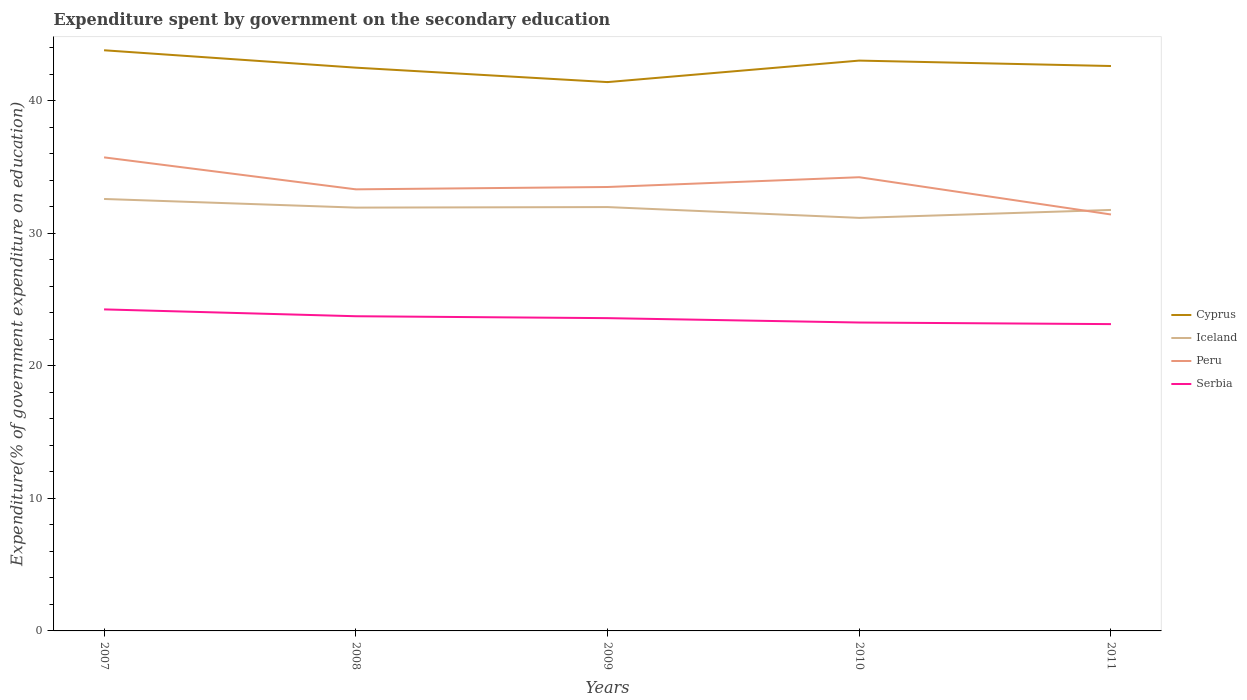How many different coloured lines are there?
Provide a short and direct response. 4. Is the number of lines equal to the number of legend labels?
Give a very brief answer. Yes. Across all years, what is the maximum expenditure spent by government on the secondary education in Iceland?
Give a very brief answer. 31.15. In which year was the expenditure spent by government on the secondary education in Serbia maximum?
Provide a short and direct response. 2011. What is the total expenditure spent by government on the secondary education in Peru in the graph?
Offer a very short reply. -0.74. What is the difference between the highest and the second highest expenditure spent by government on the secondary education in Serbia?
Your answer should be very brief. 1.11. What is the difference between the highest and the lowest expenditure spent by government on the secondary education in Cyprus?
Offer a very short reply. 2. Is the expenditure spent by government on the secondary education in Iceland strictly greater than the expenditure spent by government on the secondary education in Serbia over the years?
Provide a short and direct response. No. How many lines are there?
Your response must be concise. 4. How many years are there in the graph?
Give a very brief answer. 5. Does the graph contain any zero values?
Offer a very short reply. No. Does the graph contain grids?
Provide a short and direct response. No. Where does the legend appear in the graph?
Your response must be concise. Center right. How many legend labels are there?
Keep it short and to the point. 4. What is the title of the graph?
Provide a succinct answer. Expenditure spent by government on the secondary education. What is the label or title of the X-axis?
Offer a terse response. Years. What is the label or title of the Y-axis?
Offer a terse response. Expenditure(% of government expenditure on education). What is the Expenditure(% of government expenditure on education) in Cyprus in 2007?
Ensure brevity in your answer.  43.79. What is the Expenditure(% of government expenditure on education) of Iceland in 2007?
Your answer should be very brief. 32.58. What is the Expenditure(% of government expenditure on education) of Peru in 2007?
Provide a short and direct response. 35.71. What is the Expenditure(% of government expenditure on education) in Serbia in 2007?
Offer a very short reply. 24.25. What is the Expenditure(% of government expenditure on education) in Cyprus in 2008?
Offer a very short reply. 42.48. What is the Expenditure(% of government expenditure on education) in Iceland in 2008?
Provide a succinct answer. 31.92. What is the Expenditure(% of government expenditure on education) in Peru in 2008?
Give a very brief answer. 33.3. What is the Expenditure(% of government expenditure on education) of Serbia in 2008?
Your response must be concise. 23.73. What is the Expenditure(% of government expenditure on education) in Cyprus in 2009?
Offer a very short reply. 41.39. What is the Expenditure(% of government expenditure on education) of Iceland in 2009?
Your answer should be very brief. 31.96. What is the Expenditure(% of government expenditure on education) of Peru in 2009?
Provide a short and direct response. 33.48. What is the Expenditure(% of government expenditure on education) in Serbia in 2009?
Offer a very short reply. 23.59. What is the Expenditure(% of government expenditure on education) in Cyprus in 2010?
Offer a very short reply. 43.01. What is the Expenditure(% of government expenditure on education) in Iceland in 2010?
Provide a succinct answer. 31.15. What is the Expenditure(% of government expenditure on education) of Peru in 2010?
Provide a succinct answer. 34.22. What is the Expenditure(% of government expenditure on education) in Serbia in 2010?
Provide a succinct answer. 23.26. What is the Expenditure(% of government expenditure on education) in Cyprus in 2011?
Make the answer very short. 42.6. What is the Expenditure(% of government expenditure on education) of Iceland in 2011?
Offer a very short reply. 31.75. What is the Expenditure(% of government expenditure on education) in Peru in 2011?
Keep it short and to the point. 31.41. What is the Expenditure(% of government expenditure on education) in Serbia in 2011?
Your answer should be compact. 23.14. Across all years, what is the maximum Expenditure(% of government expenditure on education) of Cyprus?
Provide a succinct answer. 43.79. Across all years, what is the maximum Expenditure(% of government expenditure on education) of Iceland?
Keep it short and to the point. 32.58. Across all years, what is the maximum Expenditure(% of government expenditure on education) of Peru?
Your answer should be compact. 35.71. Across all years, what is the maximum Expenditure(% of government expenditure on education) of Serbia?
Make the answer very short. 24.25. Across all years, what is the minimum Expenditure(% of government expenditure on education) of Cyprus?
Make the answer very short. 41.39. Across all years, what is the minimum Expenditure(% of government expenditure on education) in Iceland?
Offer a very short reply. 31.15. Across all years, what is the minimum Expenditure(% of government expenditure on education) in Peru?
Keep it short and to the point. 31.41. Across all years, what is the minimum Expenditure(% of government expenditure on education) in Serbia?
Your response must be concise. 23.14. What is the total Expenditure(% of government expenditure on education) of Cyprus in the graph?
Your response must be concise. 213.27. What is the total Expenditure(% of government expenditure on education) in Iceland in the graph?
Your answer should be compact. 159.36. What is the total Expenditure(% of government expenditure on education) in Peru in the graph?
Provide a short and direct response. 168.11. What is the total Expenditure(% of government expenditure on education) of Serbia in the graph?
Provide a succinct answer. 117.96. What is the difference between the Expenditure(% of government expenditure on education) in Cyprus in 2007 and that in 2008?
Your response must be concise. 1.31. What is the difference between the Expenditure(% of government expenditure on education) of Iceland in 2007 and that in 2008?
Ensure brevity in your answer.  0.65. What is the difference between the Expenditure(% of government expenditure on education) in Peru in 2007 and that in 2008?
Offer a very short reply. 2.41. What is the difference between the Expenditure(% of government expenditure on education) in Serbia in 2007 and that in 2008?
Ensure brevity in your answer.  0.52. What is the difference between the Expenditure(% of government expenditure on education) in Cyprus in 2007 and that in 2009?
Your answer should be compact. 2.4. What is the difference between the Expenditure(% of government expenditure on education) in Iceland in 2007 and that in 2009?
Provide a succinct answer. 0.61. What is the difference between the Expenditure(% of government expenditure on education) of Peru in 2007 and that in 2009?
Make the answer very short. 2.23. What is the difference between the Expenditure(% of government expenditure on education) of Serbia in 2007 and that in 2009?
Offer a terse response. 0.66. What is the difference between the Expenditure(% of government expenditure on education) in Cyprus in 2007 and that in 2010?
Provide a short and direct response. 0.78. What is the difference between the Expenditure(% of government expenditure on education) of Iceland in 2007 and that in 2010?
Offer a terse response. 1.43. What is the difference between the Expenditure(% of government expenditure on education) in Peru in 2007 and that in 2010?
Provide a short and direct response. 1.5. What is the difference between the Expenditure(% of government expenditure on education) in Serbia in 2007 and that in 2010?
Ensure brevity in your answer.  0.99. What is the difference between the Expenditure(% of government expenditure on education) in Cyprus in 2007 and that in 2011?
Provide a succinct answer. 1.19. What is the difference between the Expenditure(% of government expenditure on education) in Iceland in 2007 and that in 2011?
Ensure brevity in your answer.  0.83. What is the difference between the Expenditure(% of government expenditure on education) of Peru in 2007 and that in 2011?
Provide a short and direct response. 4.31. What is the difference between the Expenditure(% of government expenditure on education) in Serbia in 2007 and that in 2011?
Offer a very short reply. 1.11. What is the difference between the Expenditure(% of government expenditure on education) of Cyprus in 2008 and that in 2009?
Provide a short and direct response. 1.09. What is the difference between the Expenditure(% of government expenditure on education) in Iceland in 2008 and that in 2009?
Offer a terse response. -0.04. What is the difference between the Expenditure(% of government expenditure on education) in Peru in 2008 and that in 2009?
Provide a short and direct response. -0.18. What is the difference between the Expenditure(% of government expenditure on education) of Serbia in 2008 and that in 2009?
Provide a short and direct response. 0.14. What is the difference between the Expenditure(% of government expenditure on education) in Cyprus in 2008 and that in 2010?
Offer a very short reply. -0.53. What is the difference between the Expenditure(% of government expenditure on education) in Iceland in 2008 and that in 2010?
Make the answer very short. 0.77. What is the difference between the Expenditure(% of government expenditure on education) of Peru in 2008 and that in 2010?
Your answer should be compact. -0.91. What is the difference between the Expenditure(% of government expenditure on education) in Serbia in 2008 and that in 2010?
Give a very brief answer. 0.47. What is the difference between the Expenditure(% of government expenditure on education) of Cyprus in 2008 and that in 2011?
Provide a succinct answer. -0.12. What is the difference between the Expenditure(% of government expenditure on education) in Iceland in 2008 and that in 2011?
Keep it short and to the point. 0.18. What is the difference between the Expenditure(% of government expenditure on education) in Peru in 2008 and that in 2011?
Provide a succinct answer. 1.9. What is the difference between the Expenditure(% of government expenditure on education) in Serbia in 2008 and that in 2011?
Make the answer very short. 0.59. What is the difference between the Expenditure(% of government expenditure on education) in Cyprus in 2009 and that in 2010?
Ensure brevity in your answer.  -1.62. What is the difference between the Expenditure(% of government expenditure on education) of Iceland in 2009 and that in 2010?
Offer a very short reply. 0.81. What is the difference between the Expenditure(% of government expenditure on education) in Peru in 2009 and that in 2010?
Provide a succinct answer. -0.74. What is the difference between the Expenditure(% of government expenditure on education) of Serbia in 2009 and that in 2010?
Your response must be concise. 0.33. What is the difference between the Expenditure(% of government expenditure on education) in Cyprus in 2009 and that in 2011?
Ensure brevity in your answer.  -1.21. What is the difference between the Expenditure(% of government expenditure on education) in Iceland in 2009 and that in 2011?
Your response must be concise. 0.22. What is the difference between the Expenditure(% of government expenditure on education) in Peru in 2009 and that in 2011?
Provide a short and direct response. 2.07. What is the difference between the Expenditure(% of government expenditure on education) of Serbia in 2009 and that in 2011?
Your answer should be very brief. 0.45. What is the difference between the Expenditure(% of government expenditure on education) in Cyprus in 2010 and that in 2011?
Make the answer very short. 0.41. What is the difference between the Expenditure(% of government expenditure on education) in Iceland in 2010 and that in 2011?
Your response must be concise. -0.6. What is the difference between the Expenditure(% of government expenditure on education) in Peru in 2010 and that in 2011?
Keep it short and to the point. 2.81. What is the difference between the Expenditure(% of government expenditure on education) of Serbia in 2010 and that in 2011?
Ensure brevity in your answer.  0.12. What is the difference between the Expenditure(% of government expenditure on education) in Cyprus in 2007 and the Expenditure(% of government expenditure on education) in Iceland in 2008?
Your response must be concise. 11.87. What is the difference between the Expenditure(% of government expenditure on education) of Cyprus in 2007 and the Expenditure(% of government expenditure on education) of Peru in 2008?
Your answer should be compact. 10.49. What is the difference between the Expenditure(% of government expenditure on education) in Cyprus in 2007 and the Expenditure(% of government expenditure on education) in Serbia in 2008?
Ensure brevity in your answer.  20.06. What is the difference between the Expenditure(% of government expenditure on education) of Iceland in 2007 and the Expenditure(% of government expenditure on education) of Peru in 2008?
Keep it short and to the point. -0.73. What is the difference between the Expenditure(% of government expenditure on education) of Iceland in 2007 and the Expenditure(% of government expenditure on education) of Serbia in 2008?
Provide a short and direct response. 8.84. What is the difference between the Expenditure(% of government expenditure on education) of Peru in 2007 and the Expenditure(% of government expenditure on education) of Serbia in 2008?
Make the answer very short. 11.98. What is the difference between the Expenditure(% of government expenditure on education) in Cyprus in 2007 and the Expenditure(% of government expenditure on education) in Iceland in 2009?
Give a very brief answer. 11.83. What is the difference between the Expenditure(% of government expenditure on education) in Cyprus in 2007 and the Expenditure(% of government expenditure on education) in Peru in 2009?
Provide a short and direct response. 10.31. What is the difference between the Expenditure(% of government expenditure on education) of Cyprus in 2007 and the Expenditure(% of government expenditure on education) of Serbia in 2009?
Keep it short and to the point. 20.2. What is the difference between the Expenditure(% of government expenditure on education) of Iceland in 2007 and the Expenditure(% of government expenditure on education) of Peru in 2009?
Ensure brevity in your answer.  -0.9. What is the difference between the Expenditure(% of government expenditure on education) in Iceland in 2007 and the Expenditure(% of government expenditure on education) in Serbia in 2009?
Make the answer very short. 8.99. What is the difference between the Expenditure(% of government expenditure on education) of Peru in 2007 and the Expenditure(% of government expenditure on education) of Serbia in 2009?
Your answer should be very brief. 12.12. What is the difference between the Expenditure(% of government expenditure on education) in Cyprus in 2007 and the Expenditure(% of government expenditure on education) in Iceland in 2010?
Give a very brief answer. 12.64. What is the difference between the Expenditure(% of government expenditure on education) in Cyprus in 2007 and the Expenditure(% of government expenditure on education) in Peru in 2010?
Your answer should be compact. 9.57. What is the difference between the Expenditure(% of government expenditure on education) in Cyprus in 2007 and the Expenditure(% of government expenditure on education) in Serbia in 2010?
Provide a short and direct response. 20.53. What is the difference between the Expenditure(% of government expenditure on education) of Iceland in 2007 and the Expenditure(% of government expenditure on education) of Peru in 2010?
Offer a terse response. -1.64. What is the difference between the Expenditure(% of government expenditure on education) in Iceland in 2007 and the Expenditure(% of government expenditure on education) in Serbia in 2010?
Offer a terse response. 9.32. What is the difference between the Expenditure(% of government expenditure on education) in Peru in 2007 and the Expenditure(% of government expenditure on education) in Serbia in 2010?
Ensure brevity in your answer.  12.45. What is the difference between the Expenditure(% of government expenditure on education) of Cyprus in 2007 and the Expenditure(% of government expenditure on education) of Iceland in 2011?
Your response must be concise. 12.04. What is the difference between the Expenditure(% of government expenditure on education) of Cyprus in 2007 and the Expenditure(% of government expenditure on education) of Peru in 2011?
Offer a very short reply. 12.38. What is the difference between the Expenditure(% of government expenditure on education) of Cyprus in 2007 and the Expenditure(% of government expenditure on education) of Serbia in 2011?
Make the answer very short. 20.65. What is the difference between the Expenditure(% of government expenditure on education) of Iceland in 2007 and the Expenditure(% of government expenditure on education) of Peru in 2011?
Provide a succinct answer. 1.17. What is the difference between the Expenditure(% of government expenditure on education) of Iceland in 2007 and the Expenditure(% of government expenditure on education) of Serbia in 2011?
Your answer should be very brief. 9.44. What is the difference between the Expenditure(% of government expenditure on education) of Peru in 2007 and the Expenditure(% of government expenditure on education) of Serbia in 2011?
Ensure brevity in your answer.  12.57. What is the difference between the Expenditure(% of government expenditure on education) in Cyprus in 2008 and the Expenditure(% of government expenditure on education) in Iceland in 2009?
Your answer should be very brief. 10.51. What is the difference between the Expenditure(% of government expenditure on education) in Cyprus in 2008 and the Expenditure(% of government expenditure on education) in Peru in 2009?
Ensure brevity in your answer.  9. What is the difference between the Expenditure(% of government expenditure on education) of Cyprus in 2008 and the Expenditure(% of government expenditure on education) of Serbia in 2009?
Offer a terse response. 18.89. What is the difference between the Expenditure(% of government expenditure on education) of Iceland in 2008 and the Expenditure(% of government expenditure on education) of Peru in 2009?
Give a very brief answer. -1.55. What is the difference between the Expenditure(% of government expenditure on education) of Iceland in 2008 and the Expenditure(% of government expenditure on education) of Serbia in 2009?
Keep it short and to the point. 8.34. What is the difference between the Expenditure(% of government expenditure on education) of Peru in 2008 and the Expenditure(% of government expenditure on education) of Serbia in 2009?
Your answer should be very brief. 9.71. What is the difference between the Expenditure(% of government expenditure on education) in Cyprus in 2008 and the Expenditure(% of government expenditure on education) in Iceland in 2010?
Make the answer very short. 11.33. What is the difference between the Expenditure(% of government expenditure on education) of Cyprus in 2008 and the Expenditure(% of government expenditure on education) of Peru in 2010?
Make the answer very short. 8.26. What is the difference between the Expenditure(% of government expenditure on education) in Cyprus in 2008 and the Expenditure(% of government expenditure on education) in Serbia in 2010?
Offer a terse response. 19.22. What is the difference between the Expenditure(% of government expenditure on education) of Iceland in 2008 and the Expenditure(% of government expenditure on education) of Peru in 2010?
Provide a succinct answer. -2.29. What is the difference between the Expenditure(% of government expenditure on education) in Iceland in 2008 and the Expenditure(% of government expenditure on education) in Serbia in 2010?
Provide a succinct answer. 8.66. What is the difference between the Expenditure(% of government expenditure on education) in Peru in 2008 and the Expenditure(% of government expenditure on education) in Serbia in 2010?
Give a very brief answer. 10.04. What is the difference between the Expenditure(% of government expenditure on education) of Cyprus in 2008 and the Expenditure(% of government expenditure on education) of Iceland in 2011?
Your response must be concise. 10.73. What is the difference between the Expenditure(% of government expenditure on education) of Cyprus in 2008 and the Expenditure(% of government expenditure on education) of Peru in 2011?
Make the answer very short. 11.07. What is the difference between the Expenditure(% of government expenditure on education) of Cyprus in 2008 and the Expenditure(% of government expenditure on education) of Serbia in 2011?
Your answer should be compact. 19.34. What is the difference between the Expenditure(% of government expenditure on education) of Iceland in 2008 and the Expenditure(% of government expenditure on education) of Peru in 2011?
Give a very brief answer. 0.52. What is the difference between the Expenditure(% of government expenditure on education) in Iceland in 2008 and the Expenditure(% of government expenditure on education) in Serbia in 2011?
Make the answer very short. 8.79. What is the difference between the Expenditure(% of government expenditure on education) in Peru in 2008 and the Expenditure(% of government expenditure on education) in Serbia in 2011?
Ensure brevity in your answer.  10.16. What is the difference between the Expenditure(% of government expenditure on education) of Cyprus in 2009 and the Expenditure(% of government expenditure on education) of Iceland in 2010?
Give a very brief answer. 10.24. What is the difference between the Expenditure(% of government expenditure on education) of Cyprus in 2009 and the Expenditure(% of government expenditure on education) of Peru in 2010?
Offer a terse response. 7.17. What is the difference between the Expenditure(% of government expenditure on education) in Cyprus in 2009 and the Expenditure(% of government expenditure on education) in Serbia in 2010?
Your response must be concise. 18.13. What is the difference between the Expenditure(% of government expenditure on education) in Iceland in 2009 and the Expenditure(% of government expenditure on education) in Peru in 2010?
Provide a short and direct response. -2.25. What is the difference between the Expenditure(% of government expenditure on education) of Iceland in 2009 and the Expenditure(% of government expenditure on education) of Serbia in 2010?
Offer a terse response. 8.71. What is the difference between the Expenditure(% of government expenditure on education) of Peru in 2009 and the Expenditure(% of government expenditure on education) of Serbia in 2010?
Ensure brevity in your answer.  10.22. What is the difference between the Expenditure(% of government expenditure on education) of Cyprus in 2009 and the Expenditure(% of government expenditure on education) of Iceland in 2011?
Your response must be concise. 9.64. What is the difference between the Expenditure(% of government expenditure on education) in Cyprus in 2009 and the Expenditure(% of government expenditure on education) in Peru in 2011?
Ensure brevity in your answer.  9.98. What is the difference between the Expenditure(% of government expenditure on education) in Cyprus in 2009 and the Expenditure(% of government expenditure on education) in Serbia in 2011?
Provide a short and direct response. 18.25. What is the difference between the Expenditure(% of government expenditure on education) of Iceland in 2009 and the Expenditure(% of government expenditure on education) of Peru in 2011?
Offer a terse response. 0.56. What is the difference between the Expenditure(% of government expenditure on education) in Iceland in 2009 and the Expenditure(% of government expenditure on education) in Serbia in 2011?
Your response must be concise. 8.83. What is the difference between the Expenditure(% of government expenditure on education) in Peru in 2009 and the Expenditure(% of government expenditure on education) in Serbia in 2011?
Keep it short and to the point. 10.34. What is the difference between the Expenditure(% of government expenditure on education) of Cyprus in 2010 and the Expenditure(% of government expenditure on education) of Iceland in 2011?
Your response must be concise. 11.26. What is the difference between the Expenditure(% of government expenditure on education) in Cyprus in 2010 and the Expenditure(% of government expenditure on education) in Peru in 2011?
Your response must be concise. 11.61. What is the difference between the Expenditure(% of government expenditure on education) of Cyprus in 2010 and the Expenditure(% of government expenditure on education) of Serbia in 2011?
Provide a succinct answer. 19.87. What is the difference between the Expenditure(% of government expenditure on education) of Iceland in 2010 and the Expenditure(% of government expenditure on education) of Peru in 2011?
Offer a very short reply. -0.25. What is the difference between the Expenditure(% of government expenditure on education) in Iceland in 2010 and the Expenditure(% of government expenditure on education) in Serbia in 2011?
Offer a terse response. 8.01. What is the difference between the Expenditure(% of government expenditure on education) in Peru in 2010 and the Expenditure(% of government expenditure on education) in Serbia in 2011?
Your answer should be compact. 11.08. What is the average Expenditure(% of government expenditure on education) in Cyprus per year?
Make the answer very short. 42.65. What is the average Expenditure(% of government expenditure on education) in Iceland per year?
Offer a very short reply. 31.87. What is the average Expenditure(% of government expenditure on education) of Peru per year?
Your answer should be compact. 33.62. What is the average Expenditure(% of government expenditure on education) in Serbia per year?
Give a very brief answer. 23.59. In the year 2007, what is the difference between the Expenditure(% of government expenditure on education) of Cyprus and Expenditure(% of government expenditure on education) of Iceland?
Your answer should be compact. 11.21. In the year 2007, what is the difference between the Expenditure(% of government expenditure on education) in Cyprus and Expenditure(% of government expenditure on education) in Peru?
Your answer should be compact. 8.08. In the year 2007, what is the difference between the Expenditure(% of government expenditure on education) of Cyprus and Expenditure(% of government expenditure on education) of Serbia?
Provide a succinct answer. 19.54. In the year 2007, what is the difference between the Expenditure(% of government expenditure on education) in Iceland and Expenditure(% of government expenditure on education) in Peru?
Your response must be concise. -3.14. In the year 2007, what is the difference between the Expenditure(% of government expenditure on education) in Iceland and Expenditure(% of government expenditure on education) in Serbia?
Make the answer very short. 8.33. In the year 2007, what is the difference between the Expenditure(% of government expenditure on education) in Peru and Expenditure(% of government expenditure on education) in Serbia?
Your answer should be very brief. 11.46. In the year 2008, what is the difference between the Expenditure(% of government expenditure on education) of Cyprus and Expenditure(% of government expenditure on education) of Iceland?
Give a very brief answer. 10.56. In the year 2008, what is the difference between the Expenditure(% of government expenditure on education) in Cyprus and Expenditure(% of government expenditure on education) in Peru?
Give a very brief answer. 9.18. In the year 2008, what is the difference between the Expenditure(% of government expenditure on education) in Cyprus and Expenditure(% of government expenditure on education) in Serbia?
Offer a very short reply. 18.75. In the year 2008, what is the difference between the Expenditure(% of government expenditure on education) in Iceland and Expenditure(% of government expenditure on education) in Peru?
Offer a very short reply. -1.38. In the year 2008, what is the difference between the Expenditure(% of government expenditure on education) of Iceland and Expenditure(% of government expenditure on education) of Serbia?
Make the answer very short. 8.19. In the year 2008, what is the difference between the Expenditure(% of government expenditure on education) of Peru and Expenditure(% of government expenditure on education) of Serbia?
Offer a very short reply. 9.57. In the year 2009, what is the difference between the Expenditure(% of government expenditure on education) in Cyprus and Expenditure(% of government expenditure on education) in Iceland?
Offer a terse response. 9.42. In the year 2009, what is the difference between the Expenditure(% of government expenditure on education) of Cyprus and Expenditure(% of government expenditure on education) of Peru?
Your response must be concise. 7.91. In the year 2009, what is the difference between the Expenditure(% of government expenditure on education) of Cyprus and Expenditure(% of government expenditure on education) of Serbia?
Provide a succinct answer. 17.8. In the year 2009, what is the difference between the Expenditure(% of government expenditure on education) of Iceland and Expenditure(% of government expenditure on education) of Peru?
Make the answer very short. -1.51. In the year 2009, what is the difference between the Expenditure(% of government expenditure on education) in Iceland and Expenditure(% of government expenditure on education) in Serbia?
Make the answer very short. 8.38. In the year 2009, what is the difference between the Expenditure(% of government expenditure on education) of Peru and Expenditure(% of government expenditure on education) of Serbia?
Keep it short and to the point. 9.89. In the year 2010, what is the difference between the Expenditure(% of government expenditure on education) in Cyprus and Expenditure(% of government expenditure on education) in Iceland?
Provide a short and direct response. 11.86. In the year 2010, what is the difference between the Expenditure(% of government expenditure on education) of Cyprus and Expenditure(% of government expenditure on education) of Peru?
Provide a short and direct response. 8.8. In the year 2010, what is the difference between the Expenditure(% of government expenditure on education) in Cyprus and Expenditure(% of government expenditure on education) in Serbia?
Give a very brief answer. 19.75. In the year 2010, what is the difference between the Expenditure(% of government expenditure on education) of Iceland and Expenditure(% of government expenditure on education) of Peru?
Your response must be concise. -3.06. In the year 2010, what is the difference between the Expenditure(% of government expenditure on education) of Iceland and Expenditure(% of government expenditure on education) of Serbia?
Provide a succinct answer. 7.89. In the year 2010, what is the difference between the Expenditure(% of government expenditure on education) in Peru and Expenditure(% of government expenditure on education) in Serbia?
Keep it short and to the point. 10.96. In the year 2011, what is the difference between the Expenditure(% of government expenditure on education) of Cyprus and Expenditure(% of government expenditure on education) of Iceland?
Provide a short and direct response. 10.85. In the year 2011, what is the difference between the Expenditure(% of government expenditure on education) of Cyprus and Expenditure(% of government expenditure on education) of Peru?
Make the answer very short. 11.2. In the year 2011, what is the difference between the Expenditure(% of government expenditure on education) in Cyprus and Expenditure(% of government expenditure on education) in Serbia?
Offer a terse response. 19.46. In the year 2011, what is the difference between the Expenditure(% of government expenditure on education) of Iceland and Expenditure(% of government expenditure on education) of Peru?
Offer a terse response. 0.34. In the year 2011, what is the difference between the Expenditure(% of government expenditure on education) in Iceland and Expenditure(% of government expenditure on education) in Serbia?
Offer a very short reply. 8.61. In the year 2011, what is the difference between the Expenditure(% of government expenditure on education) in Peru and Expenditure(% of government expenditure on education) in Serbia?
Offer a very short reply. 8.27. What is the ratio of the Expenditure(% of government expenditure on education) in Cyprus in 2007 to that in 2008?
Offer a terse response. 1.03. What is the ratio of the Expenditure(% of government expenditure on education) of Iceland in 2007 to that in 2008?
Your answer should be compact. 1.02. What is the ratio of the Expenditure(% of government expenditure on education) in Peru in 2007 to that in 2008?
Provide a short and direct response. 1.07. What is the ratio of the Expenditure(% of government expenditure on education) of Serbia in 2007 to that in 2008?
Your answer should be very brief. 1.02. What is the ratio of the Expenditure(% of government expenditure on education) of Cyprus in 2007 to that in 2009?
Give a very brief answer. 1.06. What is the ratio of the Expenditure(% of government expenditure on education) of Iceland in 2007 to that in 2009?
Provide a succinct answer. 1.02. What is the ratio of the Expenditure(% of government expenditure on education) in Peru in 2007 to that in 2009?
Offer a very short reply. 1.07. What is the ratio of the Expenditure(% of government expenditure on education) in Serbia in 2007 to that in 2009?
Your answer should be very brief. 1.03. What is the ratio of the Expenditure(% of government expenditure on education) in Cyprus in 2007 to that in 2010?
Your answer should be very brief. 1.02. What is the ratio of the Expenditure(% of government expenditure on education) in Iceland in 2007 to that in 2010?
Your answer should be compact. 1.05. What is the ratio of the Expenditure(% of government expenditure on education) of Peru in 2007 to that in 2010?
Offer a terse response. 1.04. What is the ratio of the Expenditure(% of government expenditure on education) of Serbia in 2007 to that in 2010?
Your response must be concise. 1.04. What is the ratio of the Expenditure(% of government expenditure on education) of Cyprus in 2007 to that in 2011?
Offer a terse response. 1.03. What is the ratio of the Expenditure(% of government expenditure on education) in Iceland in 2007 to that in 2011?
Offer a very short reply. 1.03. What is the ratio of the Expenditure(% of government expenditure on education) of Peru in 2007 to that in 2011?
Your answer should be compact. 1.14. What is the ratio of the Expenditure(% of government expenditure on education) in Serbia in 2007 to that in 2011?
Your answer should be compact. 1.05. What is the ratio of the Expenditure(% of government expenditure on education) in Cyprus in 2008 to that in 2009?
Give a very brief answer. 1.03. What is the ratio of the Expenditure(% of government expenditure on education) of Iceland in 2008 to that in 2009?
Your answer should be compact. 1. What is the ratio of the Expenditure(% of government expenditure on education) in Cyprus in 2008 to that in 2010?
Your answer should be compact. 0.99. What is the ratio of the Expenditure(% of government expenditure on education) in Iceland in 2008 to that in 2010?
Offer a terse response. 1.02. What is the ratio of the Expenditure(% of government expenditure on education) in Peru in 2008 to that in 2010?
Ensure brevity in your answer.  0.97. What is the ratio of the Expenditure(% of government expenditure on education) of Serbia in 2008 to that in 2010?
Provide a succinct answer. 1.02. What is the ratio of the Expenditure(% of government expenditure on education) of Iceland in 2008 to that in 2011?
Provide a short and direct response. 1.01. What is the ratio of the Expenditure(% of government expenditure on education) of Peru in 2008 to that in 2011?
Your answer should be very brief. 1.06. What is the ratio of the Expenditure(% of government expenditure on education) of Serbia in 2008 to that in 2011?
Provide a succinct answer. 1.03. What is the ratio of the Expenditure(% of government expenditure on education) in Cyprus in 2009 to that in 2010?
Your answer should be very brief. 0.96. What is the ratio of the Expenditure(% of government expenditure on education) of Iceland in 2009 to that in 2010?
Keep it short and to the point. 1.03. What is the ratio of the Expenditure(% of government expenditure on education) of Peru in 2009 to that in 2010?
Your answer should be compact. 0.98. What is the ratio of the Expenditure(% of government expenditure on education) in Serbia in 2009 to that in 2010?
Your answer should be compact. 1.01. What is the ratio of the Expenditure(% of government expenditure on education) of Cyprus in 2009 to that in 2011?
Your answer should be compact. 0.97. What is the ratio of the Expenditure(% of government expenditure on education) in Iceland in 2009 to that in 2011?
Offer a very short reply. 1.01. What is the ratio of the Expenditure(% of government expenditure on education) in Peru in 2009 to that in 2011?
Your answer should be very brief. 1.07. What is the ratio of the Expenditure(% of government expenditure on education) in Serbia in 2009 to that in 2011?
Provide a short and direct response. 1.02. What is the ratio of the Expenditure(% of government expenditure on education) of Cyprus in 2010 to that in 2011?
Give a very brief answer. 1.01. What is the ratio of the Expenditure(% of government expenditure on education) of Iceland in 2010 to that in 2011?
Provide a succinct answer. 0.98. What is the ratio of the Expenditure(% of government expenditure on education) in Peru in 2010 to that in 2011?
Your answer should be compact. 1.09. What is the ratio of the Expenditure(% of government expenditure on education) of Serbia in 2010 to that in 2011?
Your answer should be compact. 1.01. What is the difference between the highest and the second highest Expenditure(% of government expenditure on education) of Cyprus?
Your response must be concise. 0.78. What is the difference between the highest and the second highest Expenditure(% of government expenditure on education) in Iceland?
Give a very brief answer. 0.61. What is the difference between the highest and the second highest Expenditure(% of government expenditure on education) of Peru?
Make the answer very short. 1.5. What is the difference between the highest and the second highest Expenditure(% of government expenditure on education) of Serbia?
Offer a terse response. 0.52. What is the difference between the highest and the lowest Expenditure(% of government expenditure on education) of Cyprus?
Your response must be concise. 2.4. What is the difference between the highest and the lowest Expenditure(% of government expenditure on education) of Iceland?
Your answer should be very brief. 1.43. What is the difference between the highest and the lowest Expenditure(% of government expenditure on education) of Peru?
Offer a terse response. 4.31. What is the difference between the highest and the lowest Expenditure(% of government expenditure on education) of Serbia?
Give a very brief answer. 1.11. 